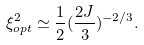<formula> <loc_0><loc_0><loc_500><loc_500>\xi _ { o p t } ^ { 2 } \simeq \frac { 1 } { 2 } ( \frac { 2 J } { 3 } ) ^ { - 2 / 3 } .</formula> 